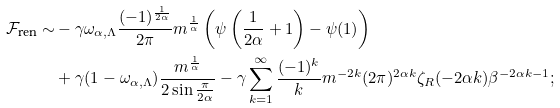<formula> <loc_0><loc_0><loc_500><loc_500>\mathcal { F } _ { \text {ren} } \sim & - \gamma \omega _ { \alpha , \Lambda } \frac { ( - 1 ) ^ { \frac { 1 } { 2 \alpha } } } { 2 \pi } m ^ { \frac { 1 } { \alpha } } \left ( \psi \left ( \frac { 1 } { 2 \alpha } + 1 \right ) - \psi ( 1 ) \right ) \\ & + \gamma ( 1 - \omega _ { \alpha , \Lambda } ) \frac { m ^ { \frac { 1 } { \alpha } } } { 2 \sin \frac { \pi } { 2 \alpha } } - \gamma \sum _ { k = 1 } ^ { \infty } \frac { ( - 1 ) ^ { k } } { k } m ^ { - 2 k } ( 2 \pi ) ^ { 2 \alpha k } \zeta _ { R } ( - 2 \alpha k ) \beta ^ { - 2 \alpha k - 1 } ;</formula> 